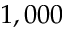Convert formula to latex. <formula><loc_0><loc_0><loc_500><loc_500>1 , 0 0 0</formula> 